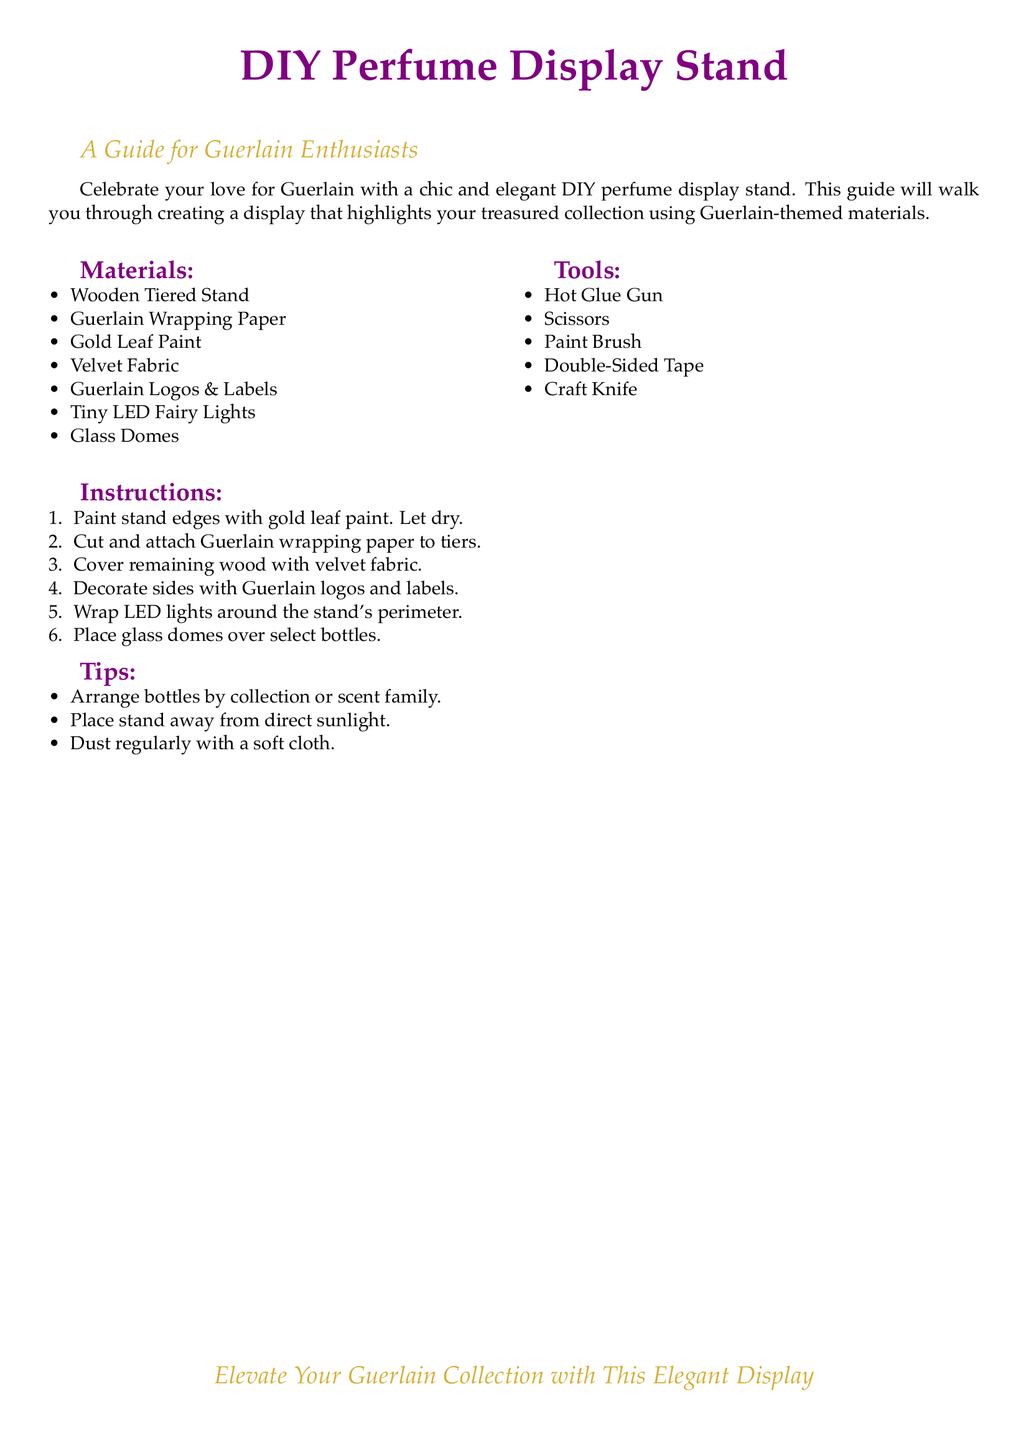What is the title of the document? The title appears at the top of the document, indicating the main subject matter.
Answer: DIY Perfume Display Stand How many materials are listed? The materials section contains a bulleted list from which we can count the items.
Answer: Seven What color is the decorative paint mentioned? The color of the paint is specified in the materials section of the document.
Answer: Gold Leaf What is the purpose of the glass domes? The last instruction hints at the intended use of these items concerning the perfume bottles.
Answer: Cover select bottles What should you use to attach the Guerlain wrapping paper? One of the tools mentioned indicates the method for attaching the wrapping paper to the stand.
Answer: Hot Glue Gun Which fabric is recommended for covering the stand? The document specifies the type of fabric to be used for covering parts of the stand.
Answer: Velvet Fabric How should bottles be arranged? The tips section offers advice on how to organize the perfume bottles aesthetically.
Answer: By collection or scent family What is one maintenance tip mentioned? The tips section includes guidance on care for the display stand.
Answer: Dust regularly with a soft cloth What type of lighting is suggested for the display? The materials list includes a specific lighting element suitable for the stand's design.
Answer: Tiny LED Fairy Lights 